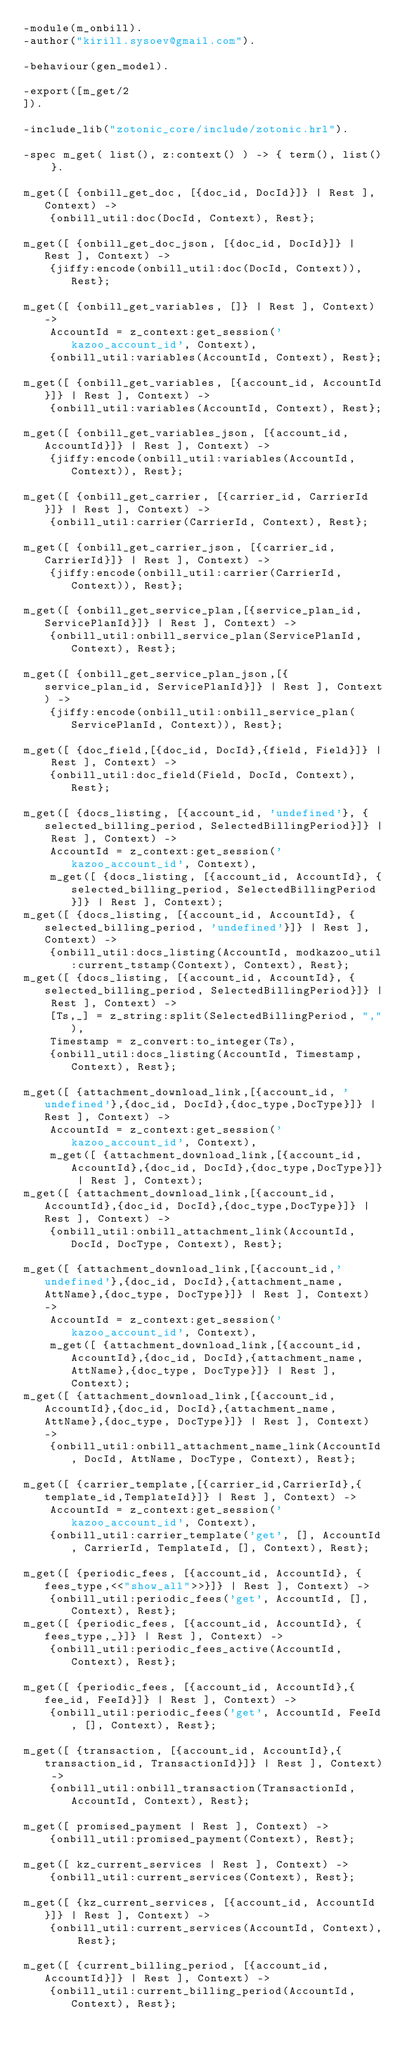Convert code to text. <code><loc_0><loc_0><loc_500><loc_500><_Erlang_>-module(m_onbill).
-author("kirill.sysoev@gmail.com").

-behaviour(gen_model).

-export([m_get/2
]).

-include_lib("zotonic_core/include/zotonic.hrl").

-spec m_get( list(), z:context() ) -> { term(), list() }.

m_get([ {onbill_get_doc, [{doc_id, DocId}]} | Rest ], Context) ->
    {onbill_util:doc(DocId, Context), Rest};

m_get([ {onbill_get_doc_json, [{doc_id, DocId}]} | Rest ], Context) ->
    {jiffy:encode(onbill_util:doc(DocId, Context)), Rest};

m_get([ {onbill_get_variables, []} | Rest ], Context) ->
    AccountId = z_context:get_session('kazoo_account_id', Context),
    {onbill_util:variables(AccountId, Context), Rest};

m_get([ {onbill_get_variables, [{account_id, AccountId}]} | Rest ], Context) ->
    {onbill_util:variables(AccountId, Context), Rest};

m_get([ {onbill_get_variables_json, [{account_id, AccountId}]} | Rest ], Context) ->
    {jiffy:encode(onbill_util:variables(AccountId, Context)), Rest};

m_get([ {onbill_get_carrier, [{carrier_id, CarrierId}]} | Rest ], Context) ->
    {onbill_util:carrier(CarrierId, Context), Rest};

m_get([ {onbill_get_carrier_json, [{carrier_id, CarrierId}]} | Rest ], Context) ->
    {jiffy:encode(onbill_util:carrier(CarrierId, Context)), Rest};

m_get([ {onbill_get_service_plan,[{service_plan_id, ServicePlanId}]} | Rest ], Context) ->
    {onbill_util:onbill_service_plan(ServicePlanId, Context), Rest};

m_get([ {onbill_get_service_plan_json,[{service_plan_id, ServicePlanId}]} | Rest ], Context) ->
    {jiffy:encode(onbill_util:onbill_service_plan(ServicePlanId, Context)), Rest};

m_get([ {doc_field,[{doc_id, DocId},{field, Field}]} | Rest ], Context) ->
    {onbill_util:doc_field(Field, DocId, Context), Rest};

m_get([ {docs_listing, [{account_id, 'undefined'}, {selected_billing_period, SelectedBillingPeriod}]} | Rest ], Context) ->
    AccountId = z_context:get_session('kazoo_account_id', Context),
    m_get([ {docs_listing, [{account_id, AccountId}, {selected_billing_period, SelectedBillingPeriod}]} | Rest ], Context);
m_get([ {docs_listing, [{account_id, AccountId}, {selected_billing_period, 'undefined'}]} | Rest ], Context) ->
    {onbill_util:docs_listing(AccountId, modkazoo_util:current_tstamp(Context), Context), Rest};
m_get([ {docs_listing, [{account_id, AccountId}, {selected_billing_period, SelectedBillingPeriod}]} | Rest ], Context) ->
    [Ts,_] = z_string:split(SelectedBillingPeriod, ","),
    Timestamp = z_convert:to_integer(Ts),
    {onbill_util:docs_listing(AccountId, Timestamp, Context), Rest};

m_get([ {attachment_download_link,[{account_id, 'undefined'},{doc_id, DocId},{doc_type,DocType}]} | Rest ], Context) ->
    AccountId = z_context:get_session('kazoo_account_id', Context),
    m_get([ {attachment_download_link,[{account_id,AccountId},{doc_id, DocId},{doc_type,DocType}]} | Rest ], Context);
m_get([ {attachment_download_link,[{account_id,AccountId},{doc_id, DocId},{doc_type,DocType}]} | Rest ], Context) ->
    {onbill_util:onbill_attachment_link(AccountId, DocId, DocType, Context), Rest};

m_get([ {attachment_download_link,[{account_id,'undefined'},{doc_id, DocId},{attachment_name, AttName},{doc_type, DocType}]} | Rest ], Context) ->
    AccountId = z_context:get_session('kazoo_account_id', Context),
    m_get([ {attachment_download_link,[{account_id,AccountId},{doc_id, DocId},{attachment_name, AttName},{doc_type, DocType}]} | Rest ], Context);
m_get([ {attachment_download_link,[{account_id,AccountId},{doc_id, DocId},{attachment_name, AttName},{doc_type, DocType}]} | Rest ], Context) ->
    {onbill_util:onbill_attachment_name_link(AccountId, DocId, AttName, DocType, Context), Rest};

m_get([ {carrier_template,[{carrier_id,CarrierId},{template_id,TemplateId}]} | Rest ], Context) ->
    AccountId = z_context:get_session('kazoo_account_id', Context),
    {onbill_util:carrier_template('get', [], AccountId, CarrierId, TemplateId, [], Context), Rest};

m_get([ {periodic_fees, [{account_id, AccountId}, {fees_type,<<"show_all">>}]} | Rest ], Context) ->
    {onbill_util:periodic_fees('get', AccountId, [], Context), Rest};
m_get([ {periodic_fees, [{account_id, AccountId}, {fees_type,_}]} | Rest ], Context) ->
    {onbill_util:periodic_fees_active(AccountId, Context), Rest};

m_get([ {periodic_fees, [{account_id, AccountId},{fee_id, FeeId}]} | Rest ], Context) ->
    {onbill_util:periodic_fees('get', AccountId, FeeId, [], Context), Rest};

m_get([ {transaction, [{account_id, AccountId},{transaction_id, TransactionId}]} | Rest ], Context) ->
    {onbill_util:onbill_transaction(TransactionId, AccountId, Context), Rest};

m_get([ promised_payment | Rest ], Context) ->
    {onbill_util:promised_payment(Context), Rest};

m_get([ kz_current_services | Rest ], Context) ->
    {onbill_util:current_services(Context), Rest};

m_get([ {kz_current_services, [{account_id, AccountId}]} | Rest ], Context) ->
    {onbill_util:current_services(AccountId, Context), Rest};

m_get([ {current_billing_period, [{account_id, AccountId}]} | Rest ], Context) ->
    {onbill_util:current_billing_period(AccountId, Context), Rest};
</code> 